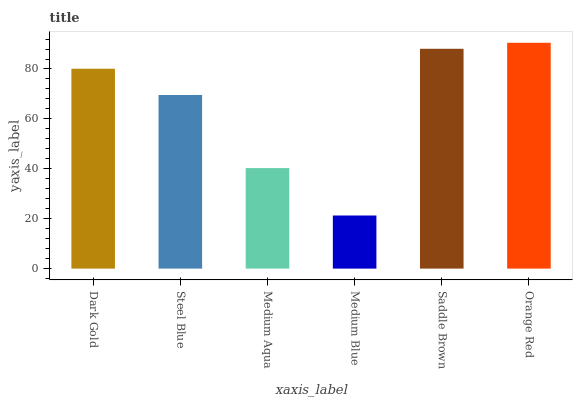Is Medium Blue the minimum?
Answer yes or no. Yes. Is Orange Red the maximum?
Answer yes or no. Yes. Is Steel Blue the minimum?
Answer yes or no. No. Is Steel Blue the maximum?
Answer yes or no. No. Is Dark Gold greater than Steel Blue?
Answer yes or no. Yes. Is Steel Blue less than Dark Gold?
Answer yes or no. Yes. Is Steel Blue greater than Dark Gold?
Answer yes or no. No. Is Dark Gold less than Steel Blue?
Answer yes or no. No. Is Dark Gold the high median?
Answer yes or no. Yes. Is Steel Blue the low median?
Answer yes or no. Yes. Is Medium Aqua the high median?
Answer yes or no. No. Is Dark Gold the low median?
Answer yes or no. No. 